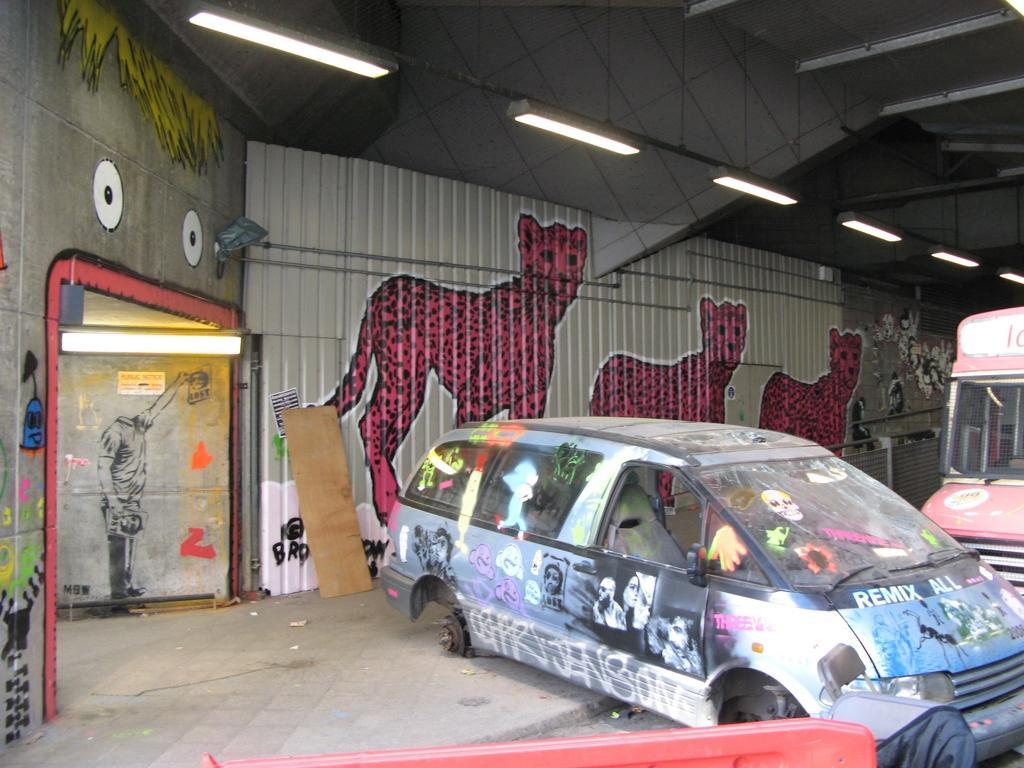Describe this image in one or two sentences. This image consists of a shed. In which we can see the cars. In the background, there are paintings on the wall. And we can see a lamp near the door. At the top, there is a roof and there are many lamps. At the bottom, there is a floor. 